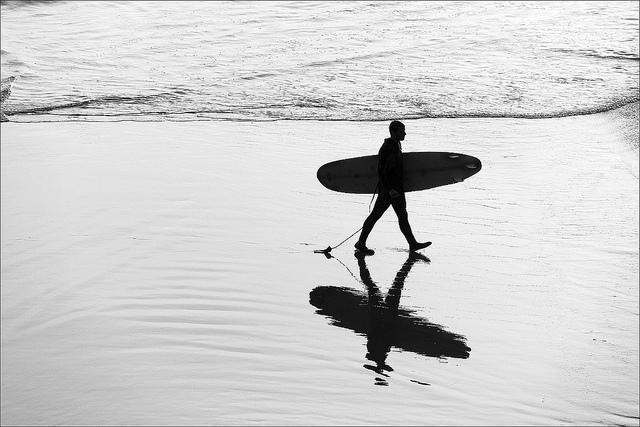How many birds are standing on the boat?
Give a very brief answer. 0. 